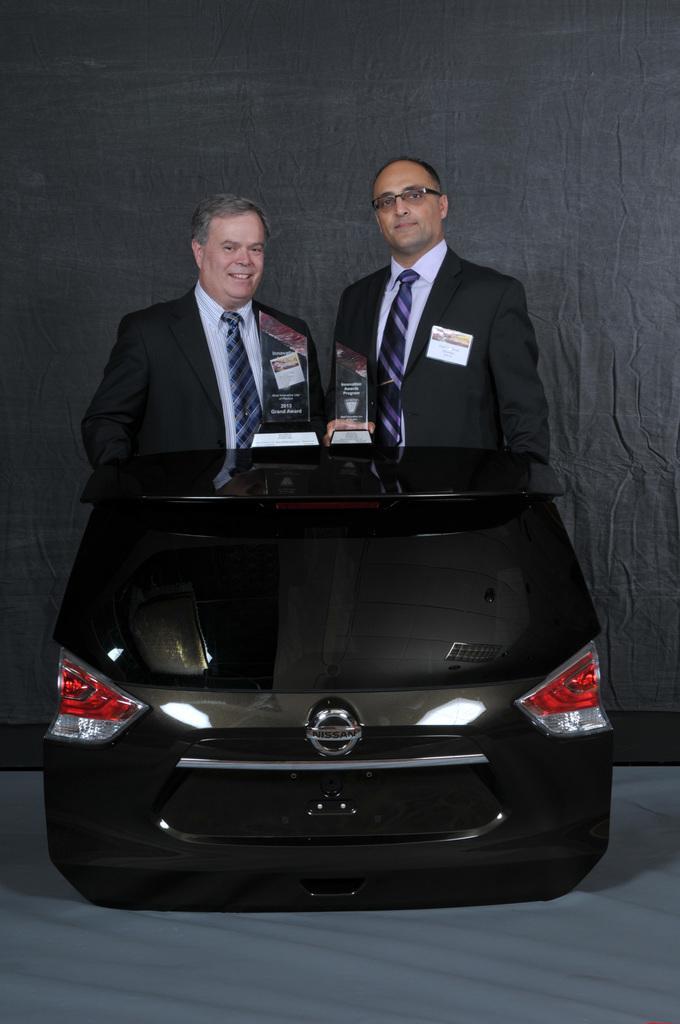In one or two sentences, can you explain what this image depicts? In this picture there are two men standing behind a car back door which is named as Nissan. There are also momentous in their hands. 